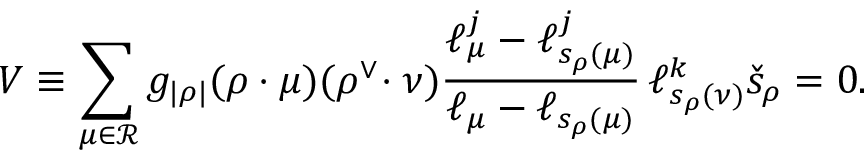Convert formula to latex. <formula><loc_0><loc_0><loc_500><loc_500>V \equiv \sum _ { \mu \in { \mathcal { R } } } g _ { | \rho | } ( \rho \cdot \mu ) ( \rho ^ { \vee } \, \cdot \nu ) \frac { \ell _ { \mu } ^ { j } - \ell _ { s _ { \rho } ( \mu ) } ^ { j } } { \ell _ { \mu } - \ell _ { s _ { \rho } ( \mu ) } } \, \ell _ { s _ { \rho } ( \nu ) } ^ { k } \check { s } _ { \rho } = 0 .</formula> 